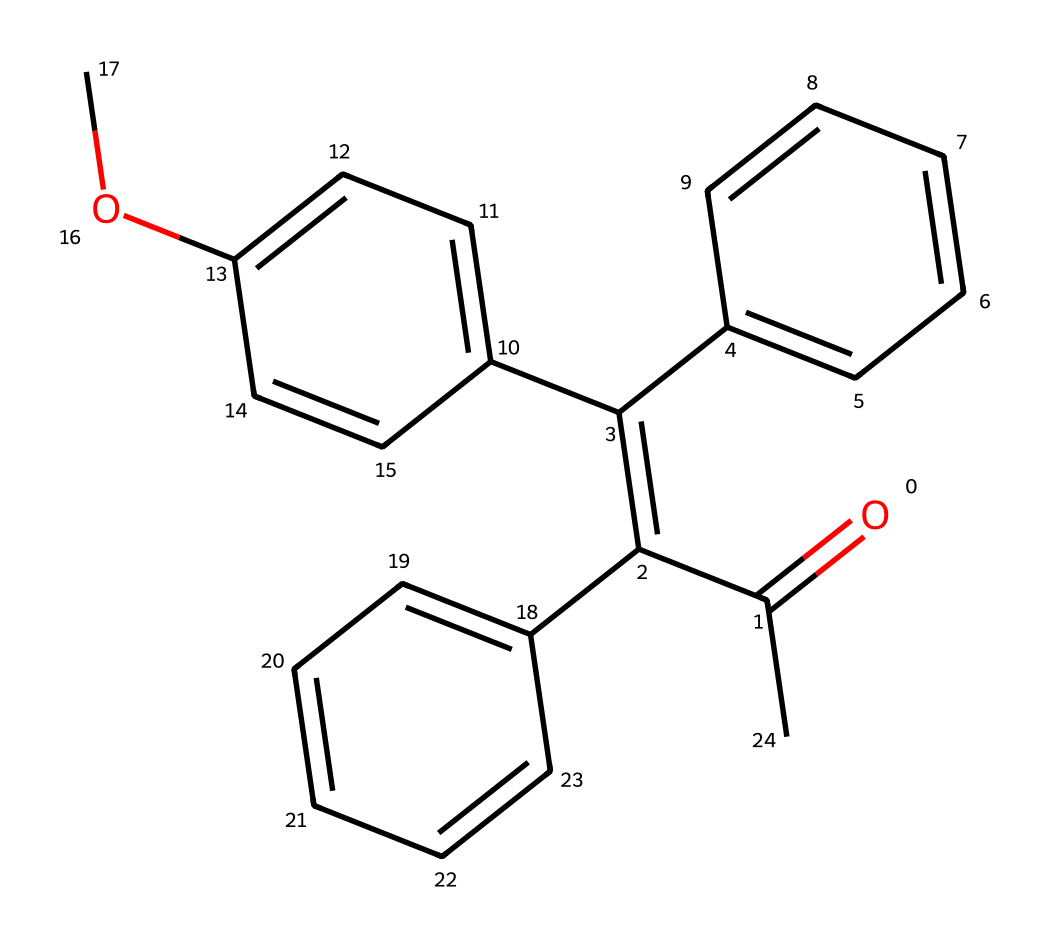What is the main functional group present in avobenzone? The chemical structure reveals a carbonyl group (C=O) as it is present in the main chain of the molecule. The carbonyl group is typically indicative of a ketone or an ester depending on its position with other groups.
Answer: carbonyl How many aromatic rings are in avobenzone's chemical structure? The chemical representation shows three distinct aromatic systems (rings) that are conjugated within the molecule, which are characteristic of many organic compounds.
Answer: three What is the molecular formula of avobenzone? To determine the molecular formula, we account for all carbon, hydrogen, and oxygen atoms present in the SMILES notation. There are 19 carbons, 22 hydrogens, and 3 oxygens, which gives the molecular formula C19H22O3.
Answer: C19H22O3 What type of chemical reaction is avobenzone likely involved in when exposed to UV light? Avobenzone acts as a photoreactive agent in sunscreen formulations and primarily undergoes a process called isomerization when exposed to UV light, which allows it to absorb a broader spectrum of UV radiation.
Answer: isomerization What is the role of avobenzone in sunscreen products? Avobenzone is primarily used as a UV filter in sunscreens to absorb UV radiation. Its chemical structure, particularly the conjugated double bonds in its rings, allows it to efficiently absorb various wavelengths of UV light, providing protection for the skin.
Answer: UV filter What characteristic of avobenzone contributes to its effectiveness in sunscreens? The extensive conjugation within the structure enables effective UV absorption across a range of wavelengths, enhancing its effectiveness in sunscreen formulations.
Answer: extensive conjugation Is avobenzone soluble in water? The molecular structure of avobenzone suggests limited solubility in water, primarily due to its large hydrophobic aromatic components, making it more soluble in organic solvents.
Answer: no 